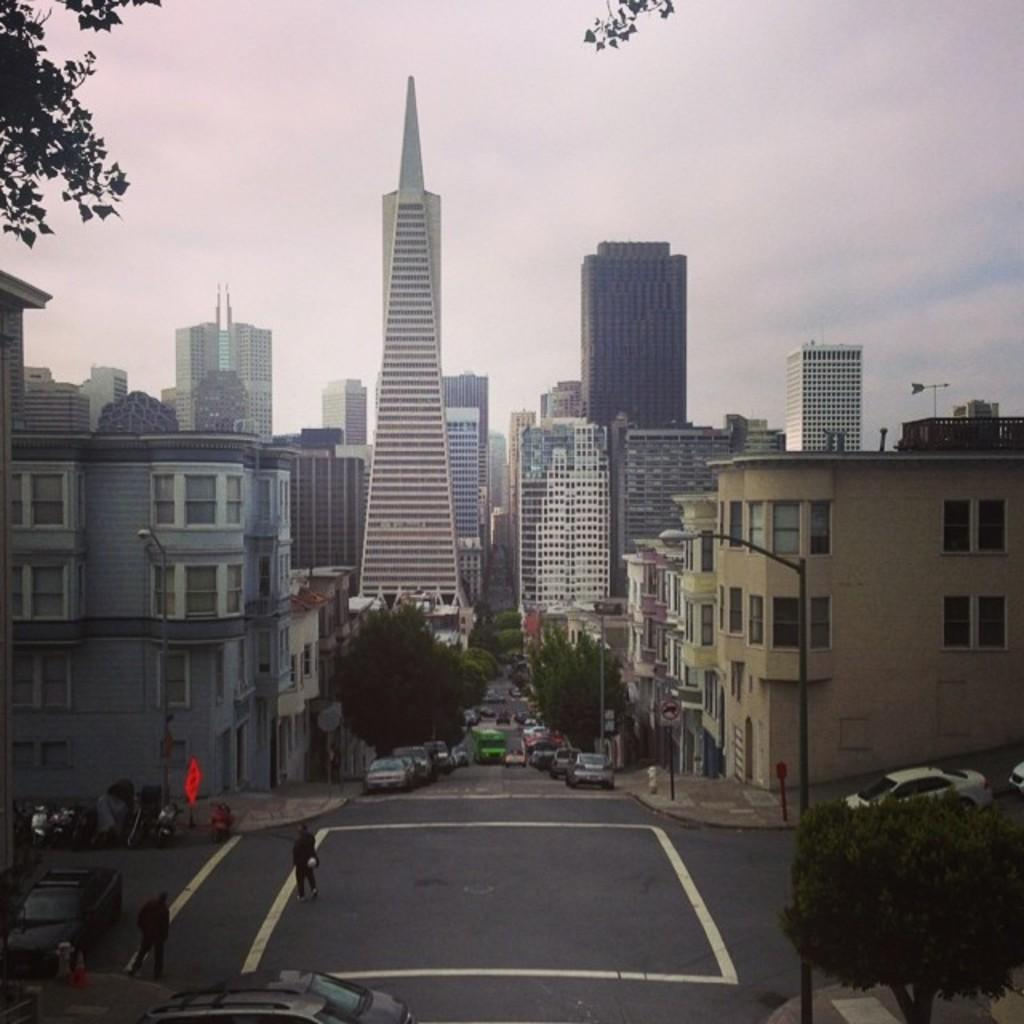What can be seen on the road in the image? There are vehicles on the road in the image. What type of structures are present in the image? There are buildings in the image. What objects are standing upright in the image? There are poles in the image. What can be seen illuminating the area in the image? There are lights in the image. What type of vegetation is present in the image? There are trees in the image. What is visible in the background of the image? The sky is visible in the background of the image. How many knives are being used to cut the trees in the image? There are no knives present in the image, and no trees are being cut. What type of fuel is being used by the vehicles in the image? The type of fuel being used by the vehicles cannot be determined from the image. 